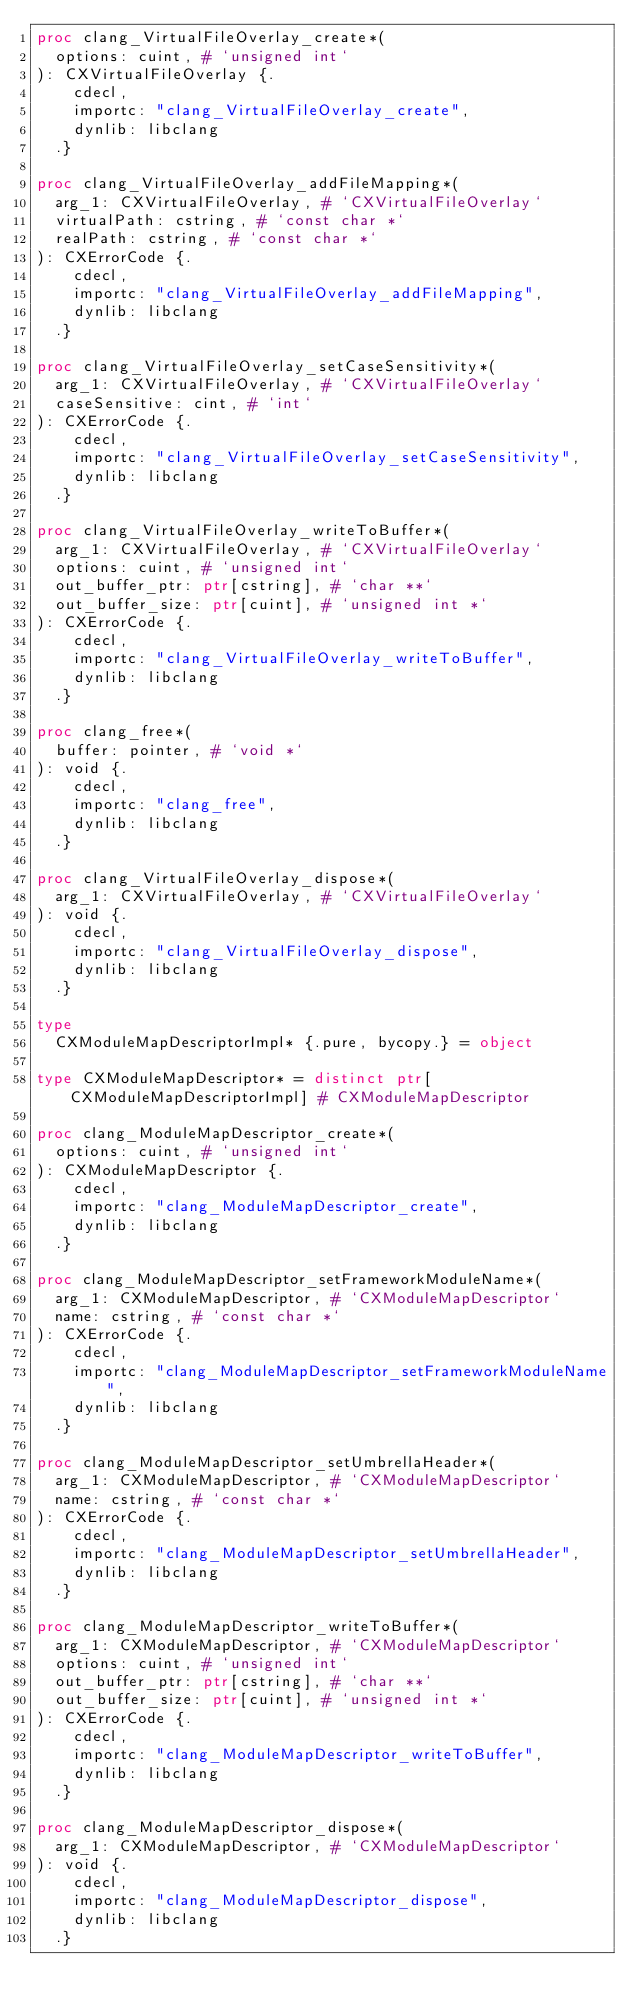<code> <loc_0><loc_0><loc_500><loc_500><_Nim_>proc clang_VirtualFileOverlay_create*(
  options: cuint, # `unsigned int`
): CXVirtualFileOverlay {.
    cdecl,
    importc: "clang_VirtualFileOverlay_create",
    dynlib: libclang
  .}

proc clang_VirtualFileOverlay_addFileMapping*(
  arg_1: CXVirtualFileOverlay, # `CXVirtualFileOverlay`
  virtualPath: cstring, # `const char *`
  realPath: cstring, # `const char *`
): CXErrorCode {.
    cdecl,
    importc: "clang_VirtualFileOverlay_addFileMapping",
    dynlib: libclang
  .}

proc clang_VirtualFileOverlay_setCaseSensitivity*(
  arg_1: CXVirtualFileOverlay, # `CXVirtualFileOverlay`
  caseSensitive: cint, # `int`
): CXErrorCode {.
    cdecl,
    importc: "clang_VirtualFileOverlay_setCaseSensitivity",
    dynlib: libclang
  .}

proc clang_VirtualFileOverlay_writeToBuffer*(
  arg_1: CXVirtualFileOverlay, # `CXVirtualFileOverlay`
  options: cuint, # `unsigned int`
  out_buffer_ptr: ptr[cstring], # `char **`
  out_buffer_size: ptr[cuint], # `unsigned int *`
): CXErrorCode {.
    cdecl,
    importc: "clang_VirtualFileOverlay_writeToBuffer",
    dynlib: libclang
  .}

proc clang_free*(
  buffer: pointer, # `void *`
): void {.
    cdecl,
    importc: "clang_free",
    dynlib: libclang
  .}

proc clang_VirtualFileOverlay_dispose*(
  arg_1: CXVirtualFileOverlay, # `CXVirtualFileOverlay`
): void {.
    cdecl,
    importc: "clang_VirtualFileOverlay_dispose",
    dynlib: libclang
  .}

type
  CXModuleMapDescriptorImpl* {.pure, bycopy.} = object

type CXModuleMapDescriptor* = distinct ptr[CXModuleMapDescriptorImpl] # CXModuleMapDescriptor

proc clang_ModuleMapDescriptor_create*(
  options: cuint, # `unsigned int`
): CXModuleMapDescriptor {.
    cdecl,
    importc: "clang_ModuleMapDescriptor_create",
    dynlib: libclang
  .}

proc clang_ModuleMapDescriptor_setFrameworkModuleName*(
  arg_1: CXModuleMapDescriptor, # `CXModuleMapDescriptor`
  name: cstring, # `const char *`
): CXErrorCode {.
    cdecl,
    importc: "clang_ModuleMapDescriptor_setFrameworkModuleName",
    dynlib: libclang
  .}

proc clang_ModuleMapDescriptor_setUmbrellaHeader*(
  arg_1: CXModuleMapDescriptor, # `CXModuleMapDescriptor`
  name: cstring, # `const char *`
): CXErrorCode {.
    cdecl,
    importc: "clang_ModuleMapDescriptor_setUmbrellaHeader",
    dynlib: libclang
  .}

proc clang_ModuleMapDescriptor_writeToBuffer*(
  arg_1: CXModuleMapDescriptor, # `CXModuleMapDescriptor`
  options: cuint, # `unsigned int`
  out_buffer_ptr: ptr[cstring], # `char **`
  out_buffer_size: ptr[cuint], # `unsigned int *`
): CXErrorCode {.
    cdecl,
    importc: "clang_ModuleMapDescriptor_writeToBuffer",
    dynlib: libclang
  .}

proc clang_ModuleMapDescriptor_dispose*(
  arg_1: CXModuleMapDescriptor, # `CXModuleMapDescriptor`
): void {.
    cdecl,
    importc: "clang_ModuleMapDescriptor_dispose",
    dynlib: libclang
  .}

</code> 